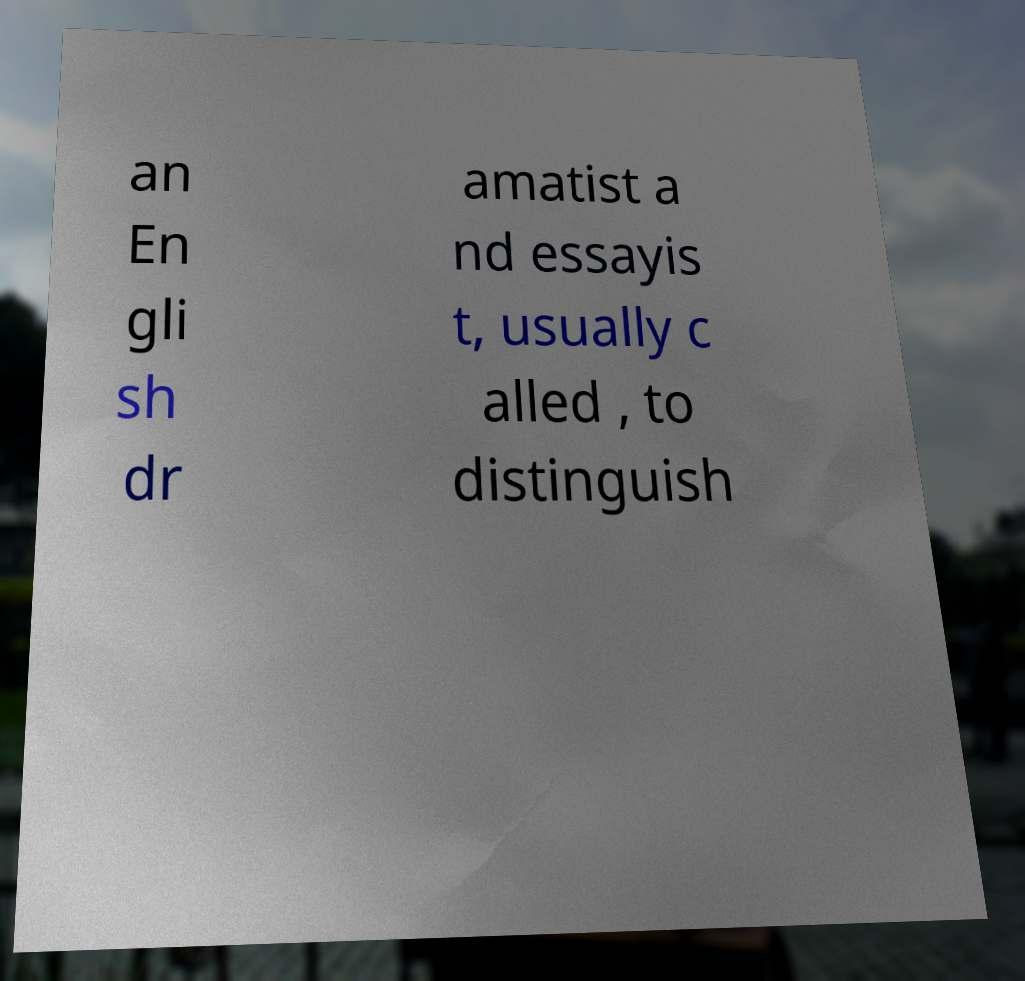Could you extract and type out the text from this image? an En gli sh dr amatist a nd essayis t, usually c alled , to distinguish 